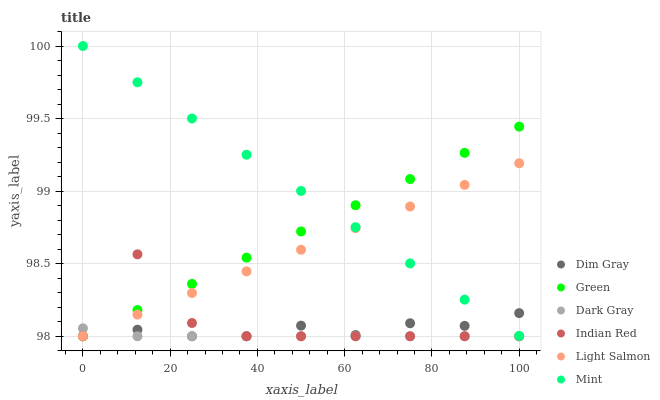Does Dark Gray have the minimum area under the curve?
Answer yes or no. Yes. Does Mint have the maximum area under the curve?
Answer yes or no. Yes. Does Dim Gray have the minimum area under the curve?
Answer yes or no. No. Does Dim Gray have the maximum area under the curve?
Answer yes or no. No. Is Mint the smoothest?
Answer yes or no. Yes. Is Indian Red the roughest?
Answer yes or no. Yes. Is Dim Gray the smoothest?
Answer yes or no. No. Is Dim Gray the roughest?
Answer yes or no. No. Does Light Salmon have the lowest value?
Answer yes or no. Yes. Does Mint have the lowest value?
Answer yes or no. No. Does Mint have the highest value?
Answer yes or no. Yes. Does Dim Gray have the highest value?
Answer yes or no. No. Is Dark Gray less than Mint?
Answer yes or no. Yes. Is Mint greater than Dark Gray?
Answer yes or no. Yes. Does Green intersect Dim Gray?
Answer yes or no. Yes. Is Green less than Dim Gray?
Answer yes or no. No. Is Green greater than Dim Gray?
Answer yes or no. No. Does Dark Gray intersect Mint?
Answer yes or no. No. 